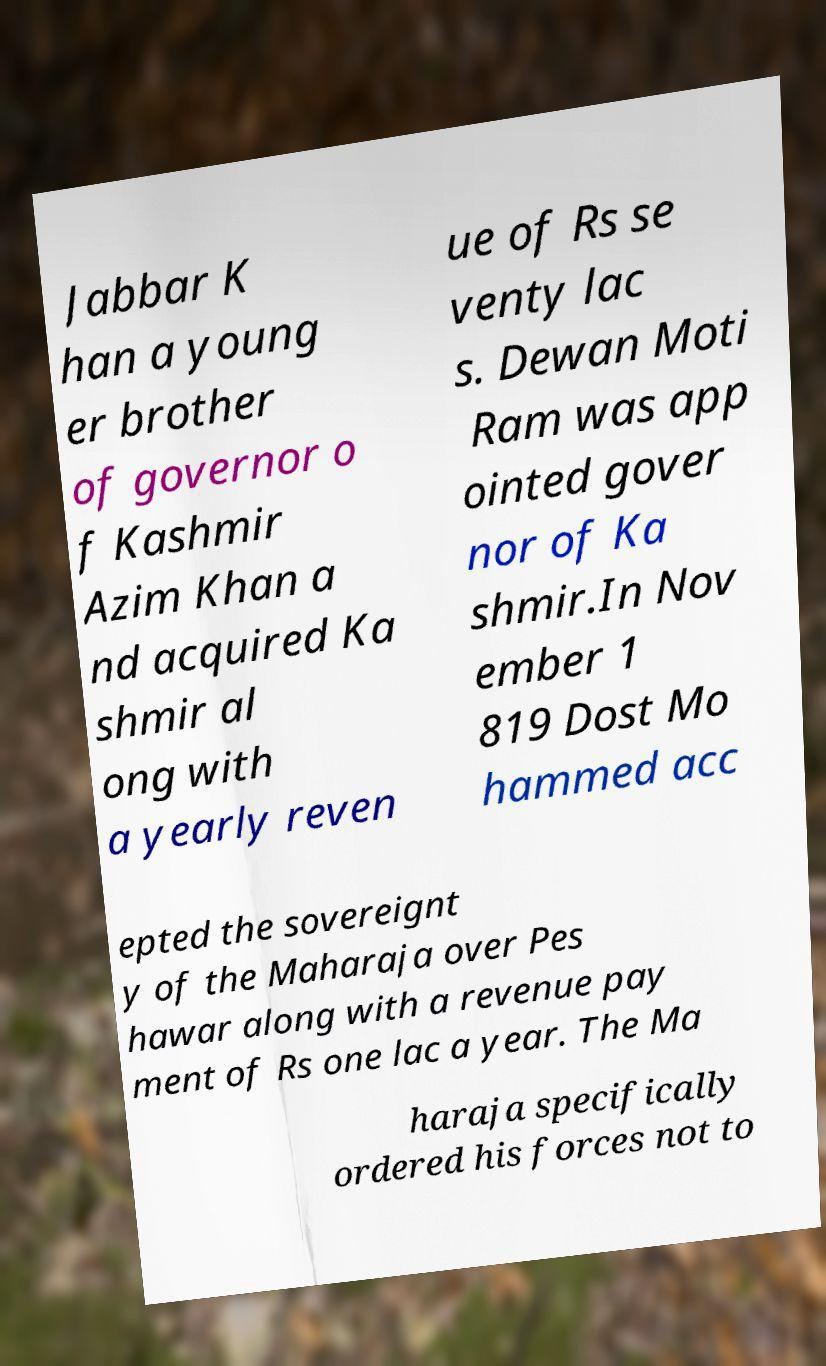Could you extract and type out the text from this image? Jabbar K han a young er brother of governor o f Kashmir Azim Khan a nd acquired Ka shmir al ong with a yearly reven ue of Rs se venty lac s. Dewan Moti Ram was app ointed gover nor of Ka shmir.In Nov ember 1 819 Dost Mo hammed acc epted the sovereignt y of the Maharaja over Pes hawar along with a revenue pay ment of Rs one lac a year. The Ma haraja specifically ordered his forces not to 